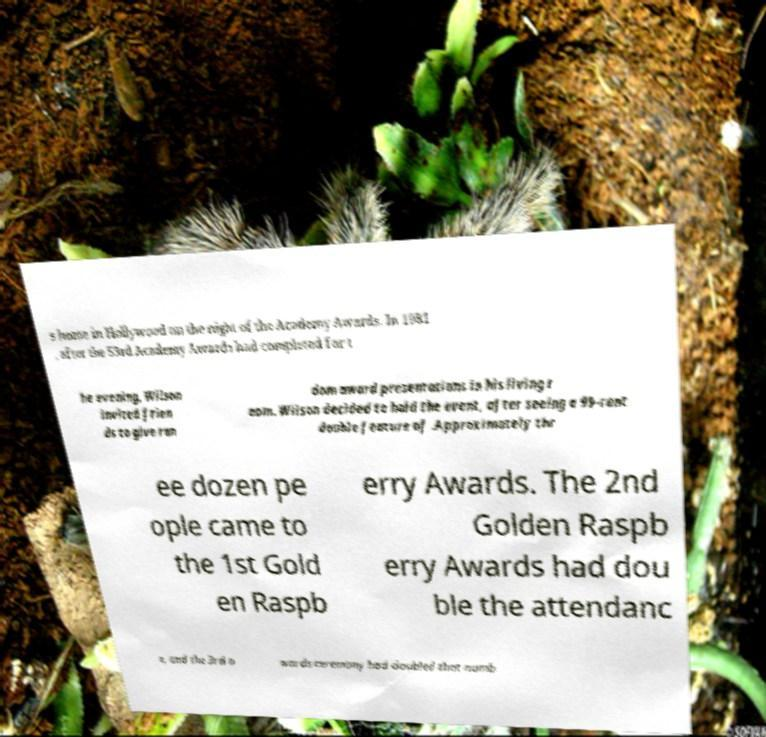For documentation purposes, I need the text within this image transcribed. Could you provide that? s home in Hollywood on the night of the Academy Awards. In 1981 , after the 53rd Academy Awards had completed for t he evening, Wilson invited frien ds to give ran dom award presentations in his living r oom. Wilson decided to hold the event, after seeing a 99-cent double feature of .Approximately thr ee dozen pe ople came to the 1st Gold en Raspb erry Awards. The 2nd Golden Raspb erry Awards had dou ble the attendanc e, and the 3rd a wards ceremony had doubled that numb 